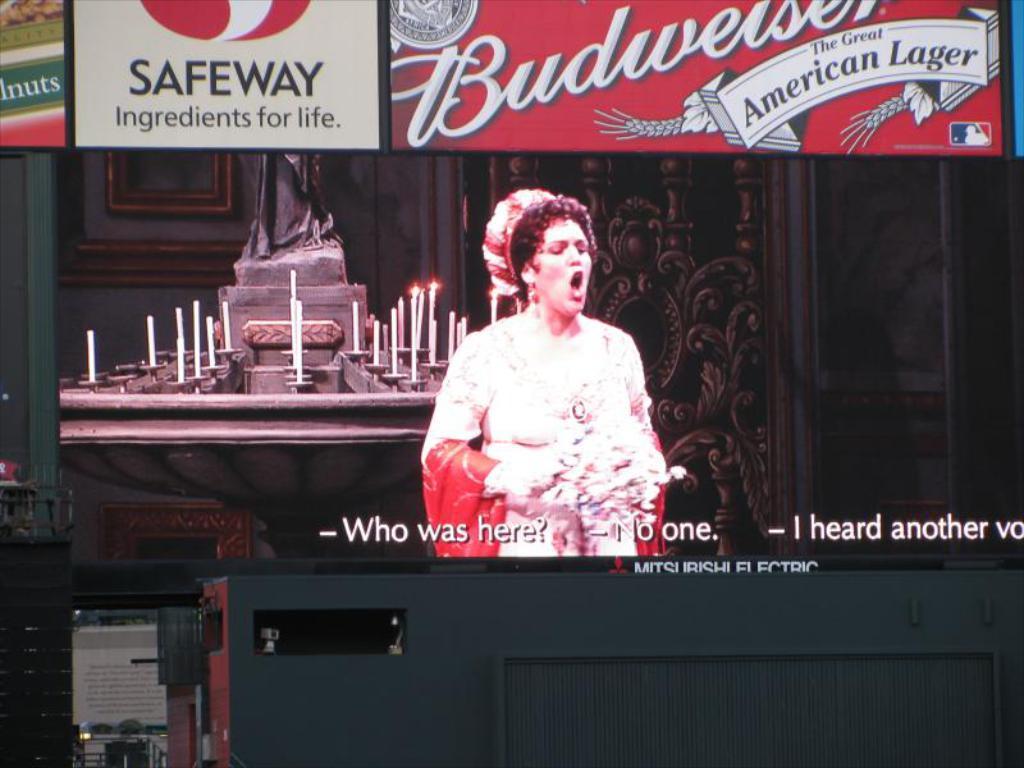Describe this image in one or two sentences. In this image I can see a woman is standing. In the background I can see candles, boards which has something written on it. Here I can see some text on the image. 